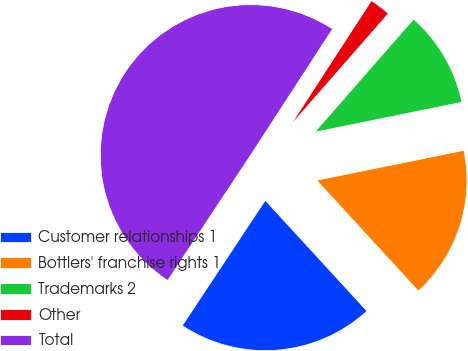<chart> <loc_0><loc_0><loc_500><loc_500><pie_chart><fcel>Customer relationships 1<fcel>Bottlers' franchise rights 1<fcel>Trademarks 2<fcel>Other<fcel>Total<nl><fcel>21.13%<fcel>16.37%<fcel>10.37%<fcel>2.27%<fcel>49.86%<nl></chart> 